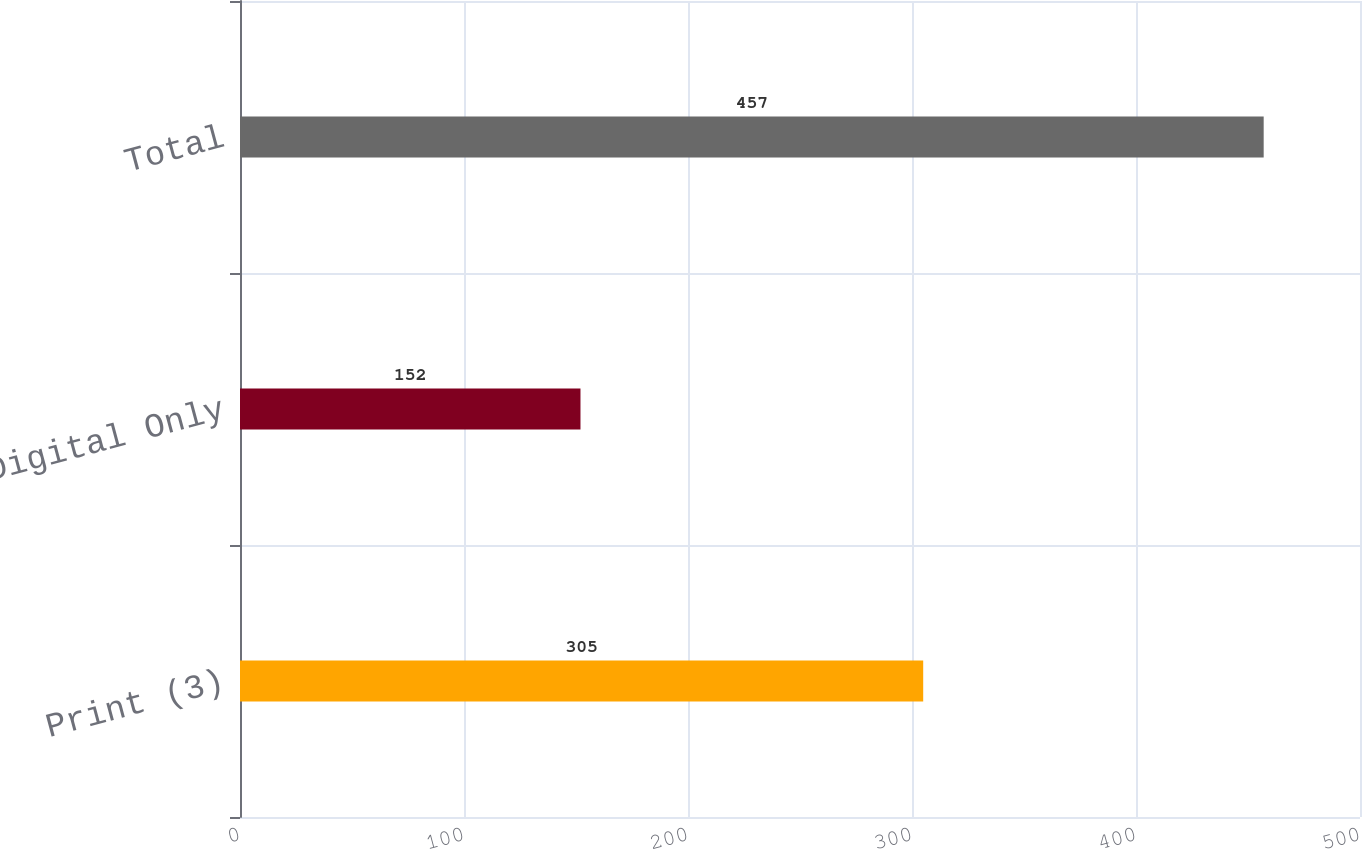Convert chart. <chart><loc_0><loc_0><loc_500><loc_500><bar_chart><fcel>Print (3)<fcel>Digital Only<fcel>Total<nl><fcel>305<fcel>152<fcel>457<nl></chart> 